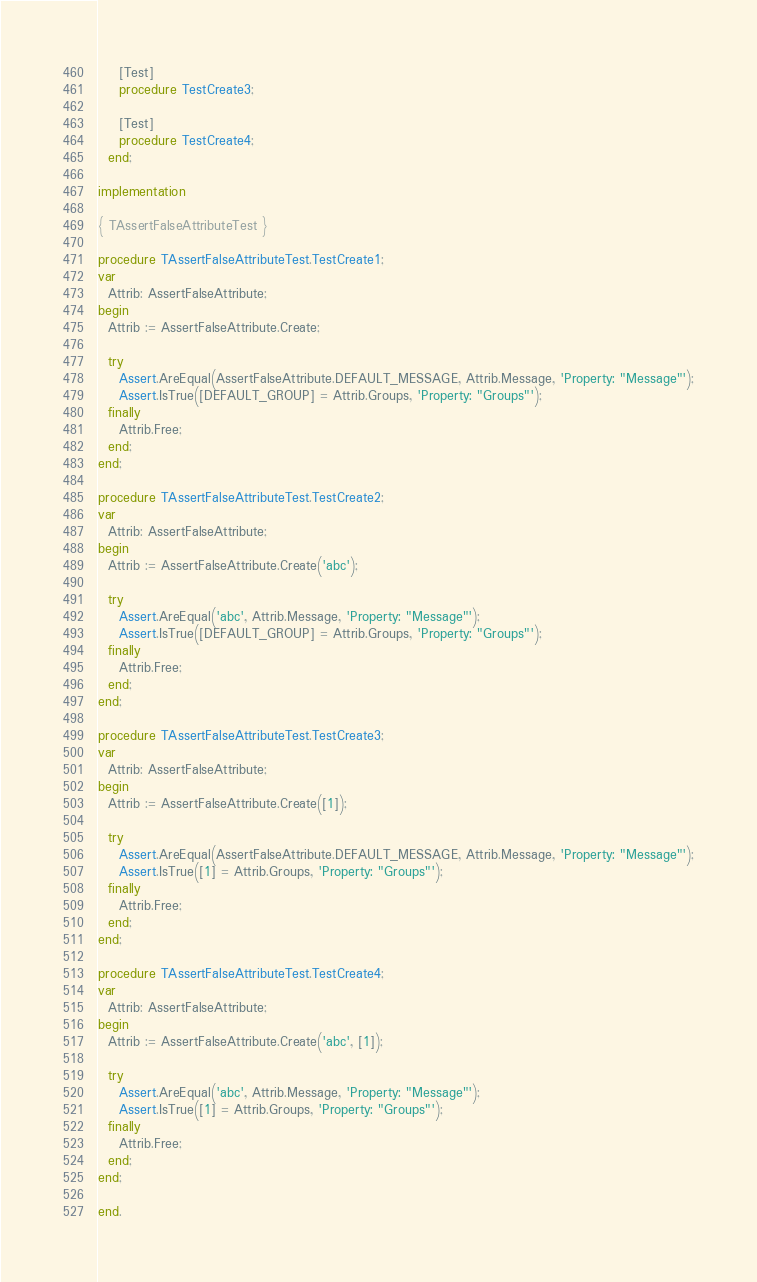Convert code to text. <code><loc_0><loc_0><loc_500><loc_500><_Pascal_>
    [Test]
    procedure TestCreate3;

    [Test]
    procedure TestCreate4;
  end;

implementation

{ TAssertFalseAttributeTest }

procedure TAssertFalseAttributeTest.TestCreate1;
var
  Attrib: AssertFalseAttribute;
begin
  Attrib := AssertFalseAttribute.Create;

  try
    Assert.AreEqual(AssertFalseAttribute.DEFAULT_MESSAGE, Attrib.Message, 'Property: "Message"');
    Assert.IsTrue([DEFAULT_GROUP] = Attrib.Groups, 'Property: "Groups"');
  finally
    Attrib.Free;
  end;
end;

procedure TAssertFalseAttributeTest.TestCreate2;
var
  Attrib: AssertFalseAttribute;
begin
  Attrib := AssertFalseAttribute.Create('abc');

  try
    Assert.AreEqual('abc', Attrib.Message, 'Property: "Message"');
    Assert.IsTrue([DEFAULT_GROUP] = Attrib.Groups, 'Property: "Groups"');
  finally
    Attrib.Free;
  end;
end;

procedure TAssertFalseAttributeTest.TestCreate3;
var
  Attrib: AssertFalseAttribute;
begin
  Attrib := AssertFalseAttribute.Create([1]);

  try
    Assert.AreEqual(AssertFalseAttribute.DEFAULT_MESSAGE, Attrib.Message, 'Property: "Message"');
    Assert.IsTrue([1] = Attrib.Groups, 'Property: "Groups"');
  finally
    Attrib.Free;
  end;
end;

procedure TAssertFalseAttributeTest.TestCreate4;
var
  Attrib: AssertFalseAttribute;
begin
  Attrib := AssertFalseAttribute.Create('abc', [1]);

  try
    Assert.AreEqual('abc', Attrib.Message, 'Property: "Message"');
    Assert.IsTrue([1] = Attrib.Groups, 'Property: "Groups"');
  finally
    Attrib.Free;
  end;
end;

end.
</code> 